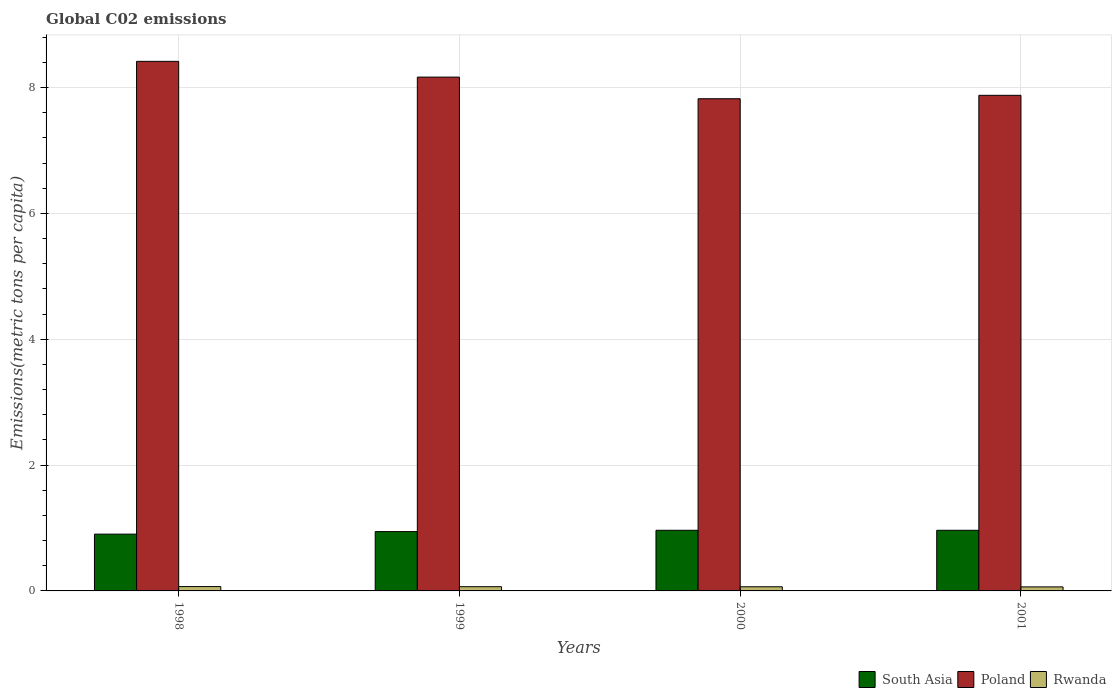How many different coloured bars are there?
Your answer should be very brief. 3. How many bars are there on the 2nd tick from the left?
Your response must be concise. 3. How many bars are there on the 2nd tick from the right?
Your answer should be very brief. 3. What is the label of the 4th group of bars from the left?
Offer a terse response. 2001. In how many cases, is the number of bars for a given year not equal to the number of legend labels?
Your response must be concise. 0. What is the amount of CO2 emitted in in Poland in 2001?
Give a very brief answer. 7.88. Across all years, what is the maximum amount of CO2 emitted in in South Asia?
Make the answer very short. 0.96. Across all years, what is the minimum amount of CO2 emitted in in Poland?
Your answer should be compact. 7.82. What is the total amount of CO2 emitted in in Poland in the graph?
Make the answer very short. 32.28. What is the difference between the amount of CO2 emitted in in Rwanda in 1998 and that in 2000?
Ensure brevity in your answer.  0. What is the difference between the amount of CO2 emitted in in Poland in 2000 and the amount of CO2 emitted in in Rwanda in 1998?
Make the answer very short. 7.75. What is the average amount of CO2 emitted in in South Asia per year?
Provide a succinct answer. 0.94. In the year 1998, what is the difference between the amount of CO2 emitted in in Poland and amount of CO2 emitted in in Rwanda?
Provide a succinct answer. 8.35. In how many years, is the amount of CO2 emitted in in Rwanda greater than 5.2 metric tons per capita?
Give a very brief answer. 0. What is the ratio of the amount of CO2 emitted in in Poland in 1998 to that in 2001?
Make the answer very short. 1.07. What is the difference between the highest and the second highest amount of CO2 emitted in in Poland?
Your answer should be very brief. 0.25. What is the difference between the highest and the lowest amount of CO2 emitted in in Rwanda?
Give a very brief answer. 0.01. Is the sum of the amount of CO2 emitted in in Poland in 1998 and 2001 greater than the maximum amount of CO2 emitted in in South Asia across all years?
Your answer should be very brief. Yes. What does the 3rd bar from the right in 2000 represents?
Offer a terse response. South Asia. Is it the case that in every year, the sum of the amount of CO2 emitted in in Rwanda and amount of CO2 emitted in in Poland is greater than the amount of CO2 emitted in in South Asia?
Give a very brief answer. Yes. How many bars are there?
Provide a succinct answer. 12. What is the difference between two consecutive major ticks on the Y-axis?
Your response must be concise. 2. Are the values on the major ticks of Y-axis written in scientific E-notation?
Your response must be concise. No. Does the graph contain any zero values?
Your answer should be compact. No. What is the title of the graph?
Make the answer very short. Global C02 emissions. What is the label or title of the Y-axis?
Your answer should be compact. Emissions(metric tons per capita). What is the Emissions(metric tons per capita) of South Asia in 1998?
Provide a succinct answer. 0.9. What is the Emissions(metric tons per capita) of Poland in 1998?
Offer a terse response. 8.42. What is the Emissions(metric tons per capita) in Rwanda in 1998?
Ensure brevity in your answer.  0.07. What is the Emissions(metric tons per capita) of South Asia in 1999?
Keep it short and to the point. 0.94. What is the Emissions(metric tons per capita) of Poland in 1999?
Offer a very short reply. 8.17. What is the Emissions(metric tons per capita) of Rwanda in 1999?
Your answer should be very brief. 0.07. What is the Emissions(metric tons per capita) in South Asia in 2000?
Your answer should be very brief. 0.96. What is the Emissions(metric tons per capita) in Poland in 2000?
Your response must be concise. 7.82. What is the Emissions(metric tons per capita) of Rwanda in 2000?
Provide a succinct answer. 0.07. What is the Emissions(metric tons per capita) of South Asia in 2001?
Ensure brevity in your answer.  0.96. What is the Emissions(metric tons per capita) of Poland in 2001?
Offer a terse response. 7.88. What is the Emissions(metric tons per capita) in Rwanda in 2001?
Your answer should be compact. 0.06. Across all years, what is the maximum Emissions(metric tons per capita) of South Asia?
Ensure brevity in your answer.  0.96. Across all years, what is the maximum Emissions(metric tons per capita) of Poland?
Give a very brief answer. 8.42. Across all years, what is the maximum Emissions(metric tons per capita) of Rwanda?
Make the answer very short. 0.07. Across all years, what is the minimum Emissions(metric tons per capita) in South Asia?
Offer a terse response. 0.9. Across all years, what is the minimum Emissions(metric tons per capita) of Poland?
Make the answer very short. 7.82. Across all years, what is the minimum Emissions(metric tons per capita) of Rwanda?
Provide a short and direct response. 0.06. What is the total Emissions(metric tons per capita) in South Asia in the graph?
Your answer should be very brief. 3.77. What is the total Emissions(metric tons per capita) of Poland in the graph?
Provide a short and direct response. 32.28. What is the total Emissions(metric tons per capita) in Rwanda in the graph?
Offer a very short reply. 0.27. What is the difference between the Emissions(metric tons per capita) of South Asia in 1998 and that in 1999?
Provide a short and direct response. -0.04. What is the difference between the Emissions(metric tons per capita) in Poland in 1998 and that in 1999?
Your answer should be very brief. 0.25. What is the difference between the Emissions(metric tons per capita) in Rwanda in 1998 and that in 1999?
Keep it short and to the point. 0. What is the difference between the Emissions(metric tons per capita) in South Asia in 1998 and that in 2000?
Ensure brevity in your answer.  -0.06. What is the difference between the Emissions(metric tons per capita) of Poland in 1998 and that in 2000?
Give a very brief answer. 0.59. What is the difference between the Emissions(metric tons per capita) of Rwanda in 1998 and that in 2000?
Provide a short and direct response. 0. What is the difference between the Emissions(metric tons per capita) of South Asia in 1998 and that in 2001?
Ensure brevity in your answer.  -0.06. What is the difference between the Emissions(metric tons per capita) in Poland in 1998 and that in 2001?
Ensure brevity in your answer.  0.54. What is the difference between the Emissions(metric tons per capita) in Rwanda in 1998 and that in 2001?
Your answer should be compact. 0.01. What is the difference between the Emissions(metric tons per capita) of South Asia in 1999 and that in 2000?
Your answer should be compact. -0.02. What is the difference between the Emissions(metric tons per capita) in Poland in 1999 and that in 2000?
Offer a very short reply. 0.34. What is the difference between the Emissions(metric tons per capita) in Rwanda in 1999 and that in 2000?
Offer a very short reply. 0. What is the difference between the Emissions(metric tons per capita) of South Asia in 1999 and that in 2001?
Your response must be concise. -0.02. What is the difference between the Emissions(metric tons per capita) of Poland in 1999 and that in 2001?
Keep it short and to the point. 0.29. What is the difference between the Emissions(metric tons per capita) of Rwanda in 1999 and that in 2001?
Your answer should be very brief. 0. What is the difference between the Emissions(metric tons per capita) in South Asia in 2000 and that in 2001?
Keep it short and to the point. 0. What is the difference between the Emissions(metric tons per capita) of Poland in 2000 and that in 2001?
Your answer should be very brief. -0.05. What is the difference between the Emissions(metric tons per capita) of Rwanda in 2000 and that in 2001?
Provide a short and direct response. 0. What is the difference between the Emissions(metric tons per capita) in South Asia in 1998 and the Emissions(metric tons per capita) in Poland in 1999?
Offer a terse response. -7.26. What is the difference between the Emissions(metric tons per capita) in South Asia in 1998 and the Emissions(metric tons per capita) in Rwanda in 1999?
Your answer should be compact. 0.84. What is the difference between the Emissions(metric tons per capita) of Poland in 1998 and the Emissions(metric tons per capita) of Rwanda in 1999?
Offer a very short reply. 8.35. What is the difference between the Emissions(metric tons per capita) in South Asia in 1998 and the Emissions(metric tons per capita) in Poland in 2000?
Ensure brevity in your answer.  -6.92. What is the difference between the Emissions(metric tons per capita) of South Asia in 1998 and the Emissions(metric tons per capita) of Rwanda in 2000?
Your response must be concise. 0.84. What is the difference between the Emissions(metric tons per capita) in Poland in 1998 and the Emissions(metric tons per capita) in Rwanda in 2000?
Keep it short and to the point. 8.35. What is the difference between the Emissions(metric tons per capita) in South Asia in 1998 and the Emissions(metric tons per capita) in Poland in 2001?
Offer a terse response. -6.97. What is the difference between the Emissions(metric tons per capita) of South Asia in 1998 and the Emissions(metric tons per capita) of Rwanda in 2001?
Provide a short and direct response. 0.84. What is the difference between the Emissions(metric tons per capita) in Poland in 1998 and the Emissions(metric tons per capita) in Rwanda in 2001?
Offer a very short reply. 8.35. What is the difference between the Emissions(metric tons per capita) of South Asia in 1999 and the Emissions(metric tons per capita) of Poland in 2000?
Ensure brevity in your answer.  -6.88. What is the difference between the Emissions(metric tons per capita) of South Asia in 1999 and the Emissions(metric tons per capita) of Rwanda in 2000?
Your response must be concise. 0.88. What is the difference between the Emissions(metric tons per capita) in Poland in 1999 and the Emissions(metric tons per capita) in Rwanda in 2000?
Keep it short and to the point. 8.1. What is the difference between the Emissions(metric tons per capita) of South Asia in 1999 and the Emissions(metric tons per capita) of Poland in 2001?
Keep it short and to the point. -6.93. What is the difference between the Emissions(metric tons per capita) of South Asia in 1999 and the Emissions(metric tons per capita) of Rwanda in 2001?
Give a very brief answer. 0.88. What is the difference between the Emissions(metric tons per capita) of Poland in 1999 and the Emissions(metric tons per capita) of Rwanda in 2001?
Offer a terse response. 8.1. What is the difference between the Emissions(metric tons per capita) in South Asia in 2000 and the Emissions(metric tons per capita) in Poland in 2001?
Offer a terse response. -6.91. What is the difference between the Emissions(metric tons per capita) of South Asia in 2000 and the Emissions(metric tons per capita) of Rwanda in 2001?
Give a very brief answer. 0.9. What is the difference between the Emissions(metric tons per capita) of Poland in 2000 and the Emissions(metric tons per capita) of Rwanda in 2001?
Ensure brevity in your answer.  7.76. What is the average Emissions(metric tons per capita) of South Asia per year?
Make the answer very short. 0.94. What is the average Emissions(metric tons per capita) of Poland per year?
Your answer should be very brief. 8.07. What is the average Emissions(metric tons per capita) in Rwanda per year?
Your answer should be compact. 0.07. In the year 1998, what is the difference between the Emissions(metric tons per capita) in South Asia and Emissions(metric tons per capita) in Poland?
Provide a succinct answer. -7.51. In the year 1998, what is the difference between the Emissions(metric tons per capita) in South Asia and Emissions(metric tons per capita) in Rwanda?
Make the answer very short. 0.83. In the year 1998, what is the difference between the Emissions(metric tons per capita) of Poland and Emissions(metric tons per capita) of Rwanda?
Offer a very short reply. 8.35. In the year 1999, what is the difference between the Emissions(metric tons per capita) in South Asia and Emissions(metric tons per capita) in Poland?
Your answer should be compact. -7.22. In the year 1999, what is the difference between the Emissions(metric tons per capita) of South Asia and Emissions(metric tons per capita) of Rwanda?
Give a very brief answer. 0.88. In the year 1999, what is the difference between the Emissions(metric tons per capita) in Poland and Emissions(metric tons per capita) in Rwanda?
Provide a short and direct response. 8.1. In the year 2000, what is the difference between the Emissions(metric tons per capita) in South Asia and Emissions(metric tons per capita) in Poland?
Your answer should be compact. -6.86. In the year 2000, what is the difference between the Emissions(metric tons per capita) in South Asia and Emissions(metric tons per capita) in Rwanda?
Your answer should be very brief. 0.9. In the year 2000, what is the difference between the Emissions(metric tons per capita) in Poland and Emissions(metric tons per capita) in Rwanda?
Provide a succinct answer. 7.76. In the year 2001, what is the difference between the Emissions(metric tons per capita) in South Asia and Emissions(metric tons per capita) in Poland?
Offer a terse response. -6.91. In the year 2001, what is the difference between the Emissions(metric tons per capita) of South Asia and Emissions(metric tons per capita) of Rwanda?
Give a very brief answer. 0.9. In the year 2001, what is the difference between the Emissions(metric tons per capita) of Poland and Emissions(metric tons per capita) of Rwanda?
Your answer should be very brief. 7.81. What is the ratio of the Emissions(metric tons per capita) of South Asia in 1998 to that in 1999?
Provide a succinct answer. 0.96. What is the ratio of the Emissions(metric tons per capita) in Poland in 1998 to that in 1999?
Make the answer very short. 1.03. What is the ratio of the Emissions(metric tons per capita) of Rwanda in 1998 to that in 1999?
Ensure brevity in your answer.  1.03. What is the ratio of the Emissions(metric tons per capita) in South Asia in 1998 to that in 2000?
Make the answer very short. 0.94. What is the ratio of the Emissions(metric tons per capita) in Poland in 1998 to that in 2000?
Offer a very short reply. 1.08. What is the ratio of the Emissions(metric tons per capita) in Rwanda in 1998 to that in 2000?
Provide a short and direct response. 1.05. What is the ratio of the Emissions(metric tons per capita) of South Asia in 1998 to that in 2001?
Your answer should be very brief. 0.94. What is the ratio of the Emissions(metric tons per capita) of Poland in 1998 to that in 2001?
Keep it short and to the point. 1.07. What is the ratio of the Emissions(metric tons per capita) of Rwanda in 1998 to that in 2001?
Make the answer very short. 1.08. What is the ratio of the Emissions(metric tons per capita) of South Asia in 1999 to that in 2000?
Keep it short and to the point. 0.98. What is the ratio of the Emissions(metric tons per capita) in Poland in 1999 to that in 2000?
Offer a very short reply. 1.04. What is the ratio of the Emissions(metric tons per capita) of Rwanda in 1999 to that in 2000?
Provide a short and direct response. 1.02. What is the ratio of the Emissions(metric tons per capita) of South Asia in 1999 to that in 2001?
Make the answer very short. 0.98. What is the ratio of the Emissions(metric tons per capita) in Poland in 1999 to that in 2001?
Offer a terse response. 1.04. What is the ratio of the Emissions(metric tons per capita) in Rwanda in 1999 to that in 2001?
Offer a very short reply. 1.05. What is the ratio of the Emissions(metric tons per capita) in South Asia in 2000 to that in 2001?
Provide a short and direct response. 1. What is the ratio of the Emissions(metric tons per capita) of Rwanda in 2000 to that in 2001?
Keep it short and to the point. 1.03. What is the difference between the highest and the second highest Emissions(metric tons per capita) in Poland?
Give a very brief answer. 0.25. What is the difference between the highest and the second highest Emissions(metric tons per capita) in Rwanda?
Provide a succinct answer. 0. What is the difference between the highest and the lowest Emissions(metric tons per capita) of South Asia?
Provide a short and direct response. 0.06. What is the difference between the highest and the lowest Emissions(metric tons per capita) in Poland?
Keep it short and to the point. 0.59. What is the difference between the highest and the lowest Emissions(metric tons per capita) in Rwanda?
Your response must be concise. 0.01. 